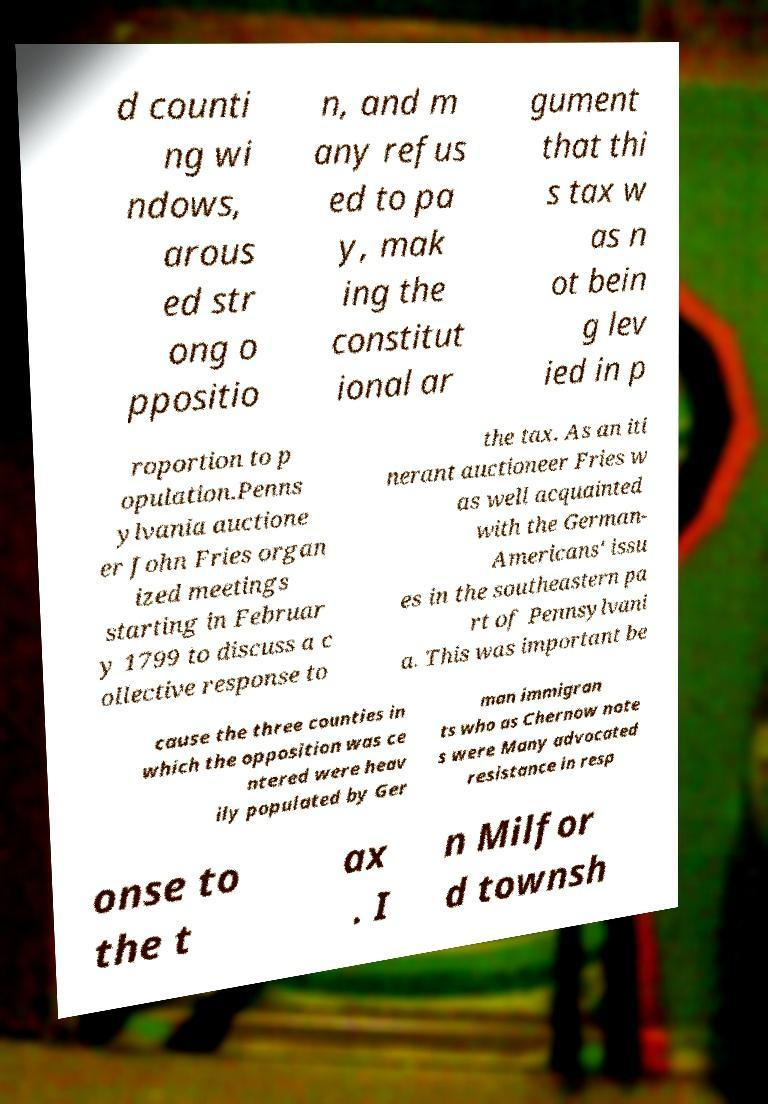I need the written content from this picture converted into text. Can you do that? d counti ng wi ndows, arous ed str ong o ppositio n, and m any refus ed to pa y, mak ing the constitut ional ar gument that thi s tax w as n ot bein g lev ied in p roportion to p opulation.Penns ylvania auctione er John Fries organ ized meetings starting in Februar y 1799 to discuss a c ollective response to the tax. As an iti nerant auctioneer Fries w as well acquainted with the German- Americans' issu es in the southeastern pa rt of Pennsylvani a. This was important be cause the three counties in which the opposition was ce ntered were heav ily populated by Ger man immigran ts who as Chernow note s were Many advocated resistance in resp onse to the t ax . I n Milfor d townsh 